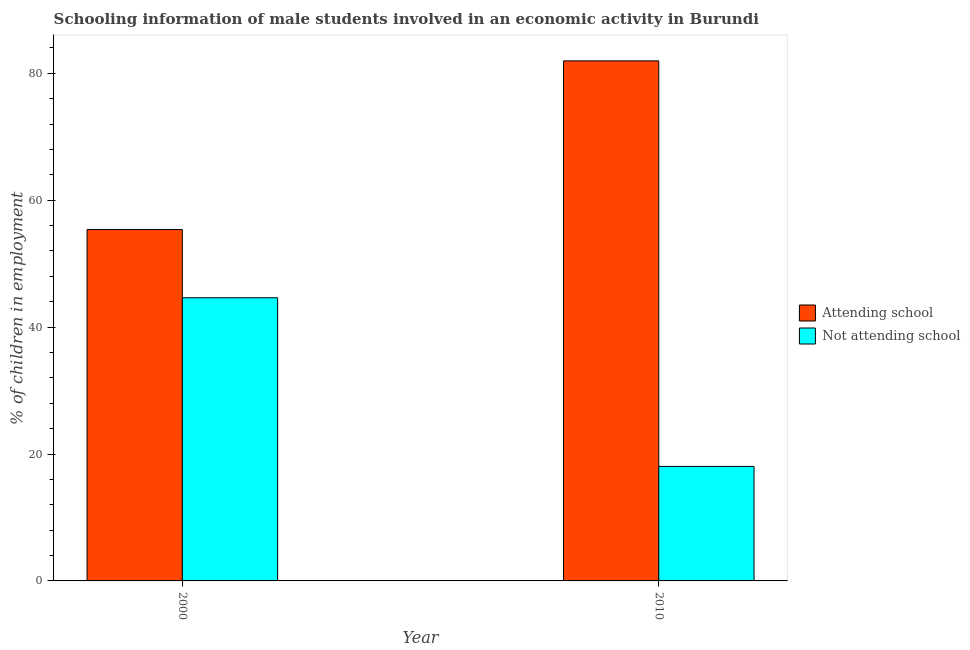How many groups of bars are there?
Your answer should be compact. 2. Are the number of bars per tick equal to the number of legend labels?
Make the answer very short. Yes. Are the number of bars on each tick of the X-axis equal?
Offer a terse response. Yes. How many bars are there on the 2nd tick from the right?
Keep it short and to the point. 2. In how many cases, is the number of bars for a given year not equal to the number of legend labels?
Keep it short and to the point. 0. What is the percentage of employed males who are not attending school in 2000?
Provide a succinct answer. 44.62. Across all years, what is the maximum percentage of employed males who are attending school?
Make the answer very short. 81.96. Across all years, what is the minimum percentage of employed males who are attending school?
Your answer should be compact. 55.38. In which year was the percentage of employed males who are not attending school maximum?
Provide a succinct answer. 2000. What is the total percentage of employed males who are attending school in the graph?
Your response must be concise. 137.33. What is the difference between the percentage of employed males who are attending school in 2000 and that in 2010?
Provide a succinct answer. -26.58. What is the difference between the percentage of employed males who are attending school in 2010 and the percentage of employed males who are not attending school in 2000?
Keep it short and to the point. 26.58. What is the average percentage of employed males who are attending school per year?
Ensure brevity in your answer.  68.67. In the year 2010, what is the difference between the percentage of employed males who are attending school and percentage of employed males who are not attending school?
Keep it short and to the point. 0. In how many years, is the percentage of employed males who are not attending school greater than 28 %?
Keep it short and to the point. 1. What is the ratio of the percentage of employed males who are not attending school in 2000 to that in 2010?
Make the answer very short. 2.47. Is the percentage of employed males who are attending school in 2000 less than that in 2010?
Your answer should be compact. Yes. What does the 1st bar from the left in 2000 represents?
Provide a succinct answer. Attending school. What does the 1st bar from the right in 2000 represents?
Your answer should be very brief. Not attending school. How many bars are there?
Provide a short and direct response. 4. How many years are there in the graph?
Ensure brevity in your answer.  2. What is the difference between two consecutive major ticks on the Y-axis?
Your answer should be very brief. 20. Does the graph contain any zero values?
Your answer should be compact. No. Where does the legend appear in the graph?
Make the answer very short. Center right. What is the title of the graph?
Offer a very short reply. Schooling information of male students involved in an economic activity in Burundi. What is the label or title of the Y-axis?
Offer a terse response. % of children in employment. What is the % of children in employment of Attending school in 2000?
Give a very brief answer. 55.38. What is the % of children in employment in Not attending school in 2000?
Ensure brevity in your answer.  44.62. What is the % of children in employment in Attending school in 2010?
Your response must be concise. 81.96. What is the % of children in employment of Not attending school in 2010?
Provide a short and direct response. 18.04. Across all years, what is the maximum % of children in employment of Attending school?
Give a very brief answer. 81.96. Across all years, what is the maximum % of children in employment of Not attending school?
Provide a short and direct response. 44.62. Across all years, what is the minimum % of children in employment of Attending school?
Give a very brief answer. 55.38. Across all years, what is the minimum % of children in employment of Not attending school?
Offer a terse response. 18.04. What is the total % of children in employment of Attending school in the graph?
Ensure brevity in your answer.  137.33. What is the total % of children in employment of Not attending school in the graph?
Your answer should be compact. 62.67. What is the difference between the % of children in employment of Attending school in 2000 and that in 2010?
Your response must be concise. -26.58. What is the difference between the % of children in employment in Not attending school in 2000 and that in 2010?
Make the answer very short. 26.58. What is the difference between the % of children in employment in Attending school in 2000 and the % of children in employment in Not attending school in 2010?
Your answer should be compact. 37.33. What is the average % of children in employment in Attending school per year?
Make the answer very short. 68.67. What is the average % of children in employment of Not attending school per year?
Keep it short and to the point. 31.33. In the year 2000, what is the difference between the % of children in employment of Attending school and % of children in employment of Not attending school?
Give a very brief answer. 10.76. In the year 2010, what is the difference between the % of children in employment of Attending school and % of children in employment of Not attending school?
Your response must be concise. 63.91. What is the ratio of the % of children in employment of Attending school in 2000 to that in 2010?
Make the answer very short. 0.68. What is the ratio of the % of children in employment of Not attending school in 2000 to that in 2010?
Offer a terse response. 2.47. What is the difference between the highest and the second highest % of children in employment of Attending school?
Provide a short and direct response. 26.58. What is the difference between the highest and the second highest % of children in employment of Not attending school?
Keep it short and to the point. 26.58. What is the difference between the highest and the lowest % of children in employment of Attending school?
Give a very brief answer. 26.58. What is the difference between the highest and the lowest % of children in employment in Not attending school?
Ensure brevity in your answer.  26.58. 